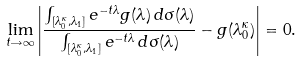<formula> <loc_0><loc_0><loc_500><loc_500>\lim _ { t \rightarrow \infty } \left | \frac { \int _ { [ \lambda _ { 0 } ^ { \kappa } , \lambda _ { 1 } ] } e ^ { - t \lambda } g ( \lambda ) \, d \sigma ( \lambda ) } { \int _ { [ \lambda _ { 0 } ^ { \kappa } , \lambda _ { 1 } ] } e ^ { - t \lambda } \, d \sigma ( \lambda ) } - g ( \lambda _ { 0 } ^ { \kappa } ) \right | = 0 .</formula> 